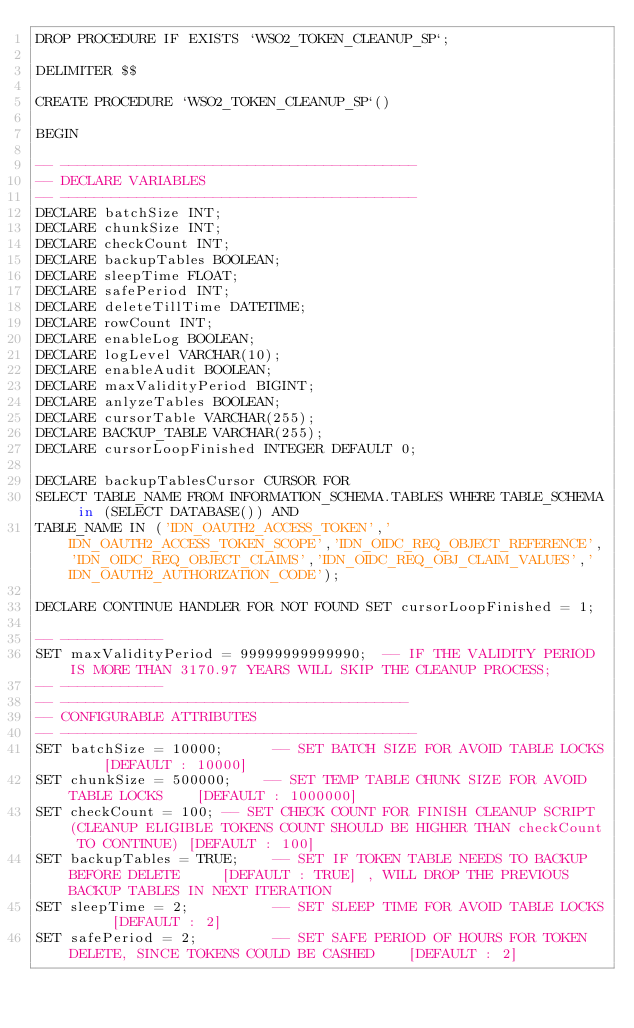Convert code to text. <code><loc_0><loc_0><loc_500><loc_500><_SQL_>DROP PROCEDURE IF EXISTS `WSO2_TOKEN_CLEANUP_SP`;

DELIMITER $$

CREATE PROCEDURE `WSO2_TOKEN_CLEANUP_SP`()

BEGIN

-- ------------------------------------------
-- DECLARE VARIABLES
-- ------------------------------------------
DECLARE batchSize INT;
DECLARE chunkSize INT;
DECLARE checkCount INT;
DECLARE backupTables BOOLEAN;
DECLARE sleepTime FLOAT;
DECLARE safePeriod INT;
DECLARE deleteTillTime DATETIME;
DECLARE rowCount INT;
DECLARE enableLog BOOLEAN;
DECLARE logLevel VARCHAR(10);
DECLARE enableAudit BOOLEAN;
DECLARE maxValidityPeriod BIGINT;
DECLARE anlyzeTables BOOLEAN;
DECLARE cursorTable VARCHAR(255);
DECLARE BACKUP_TABLE VARCHAR(255);
DECLARE cursorLoopFinished INTEGER DEFAULT 0;

DECLARE backupTablesCursor CURSOR FOR
SELECT TABLE_NAME FROM INFORMATION_SCHEMA.TABLES WHERE TABLE_SCHEMA in (SELECT DATABASE()) AND
TABLE_NAME IN ('IDN_OAUTH2_ACCESS_TOKEN','IDN_OAUTH2_ACCESS_TOKEN_SCOPE','IDN_OIDC_REQ_OBJECT_REFERENCE','IDN_OIDC_REQ_OBJECT_CLAIMS','IDN_OIDC_REQ_OBJ_CLAIM_VALUES','IDN_OAUTH2_AUTHORIZATION_CODE');

DECLARE CONTINUE HANDLER FOR NOT FOUND SET cursorLoopFinished = 1;

-- ------------
SET maxValidityPeriod = 99999999999990;  -- IF THE VALIDITY PERIOD IS MORE THAN 3170.97 YEARS WILL SKIP THE CLEANUP PROCESS;
-- ------------
-- -----------------------------------------
-- CONFIGURABLE ATTRIBUTES
-- ------------------------------------------
SET batchSize = 10000;      -- SET BATCH SIZE FOR AVOID TABLE LOCKS    [DEFAULT : 10000]
SET chunkSize = 500000;    -- SET TEMP TABLE CHUNK SIZE FOR AVOID TABLE LOCKS    [DEFAULT : 1000000]
SET checkCount = 100; -- SET CHECK COUNT FOR FINISH CLEANUP SCRIPT (CLEANUP ELIGIBLE TOKENS COUNT SHOULD BE HIGHER THAN checkCount TO CONTINUE) [DEFAULT : 100]
SET backupTables = TRUE;    -- SET IF TOKEN TABLE NEEDS TO BACKUP BEFORE DELETE     [DEFAULT : TRUE] , WILL DROP THE PREVIOUS BACKUP TABLES IN NEXT ITERATION
SET sleepTime = 2;          -- SET SLEEP TIME FOR AVOID TABLE LOCKS     [DEFAULT : 2]
SET safePeriod = 2;         -- SET SAFE PERIOD OF HOURS FOR TOKEN DELETE, SINCE TOKENS COULD BE CASHED    [DEFAULT : 2]</code> 